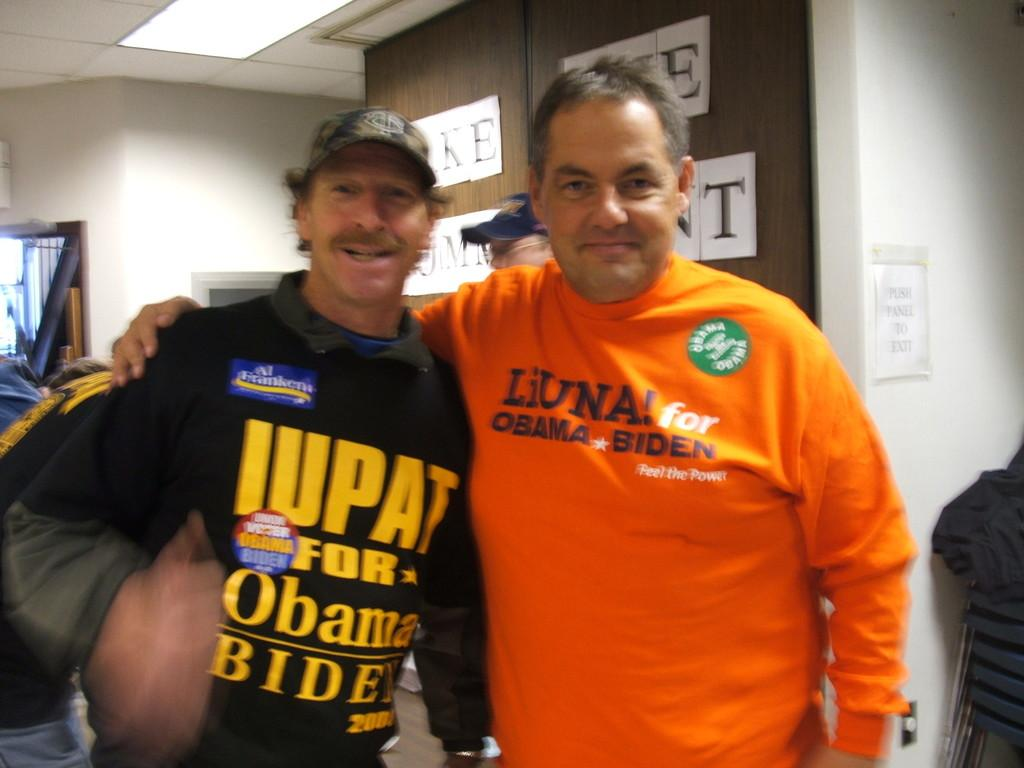Provide a one-sentence caption for the provided image. Two men at a political event wearing Obama/Biden shirts. 